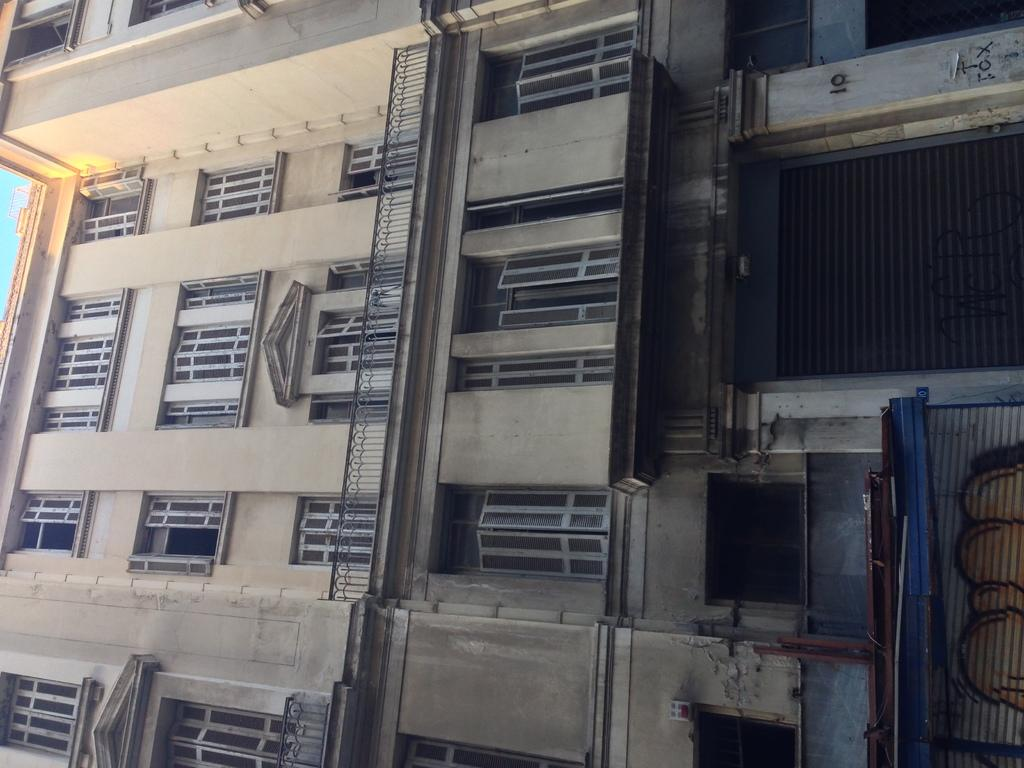What type of structure is visible in the image? There is a building in the image. What feature can be seen on the building? There is railing in the image. What type of windows are present on the building? There are glass windows in the image. What type of window covering is present on the building? There are shutters in the image. Can you describe any other objects visible in the image? There are some unspecified objects in the image. What type of pie is being served by the father in the image? There is no father or pie present in the image. 